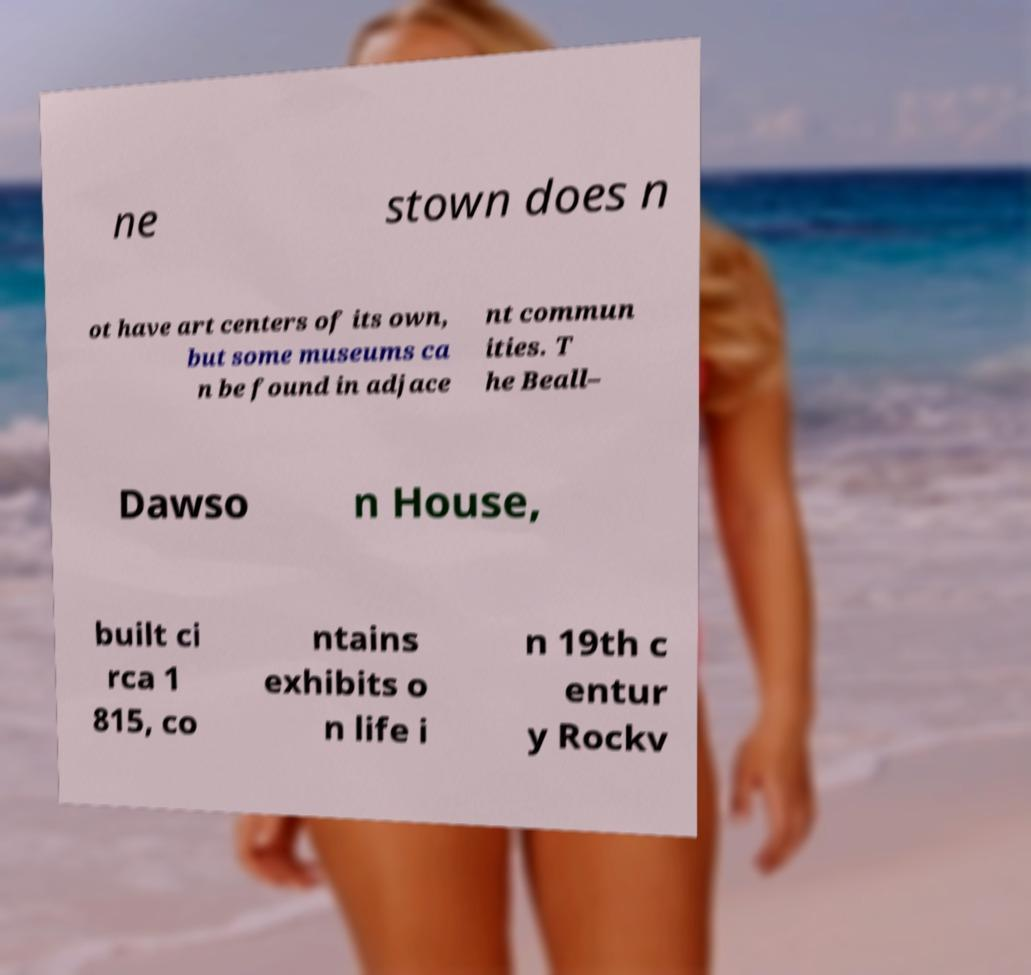There's text embedded in this image that I need extracted. Can you transcribe it verbatim? ne stown does n ot have art centers of its own, but some museums ca n be found in adjace nt commun ities. T he Beall– Dawso n House, built ci rca 1 815, co ntains exhibits o n life i n 19th c entur y Rockv 